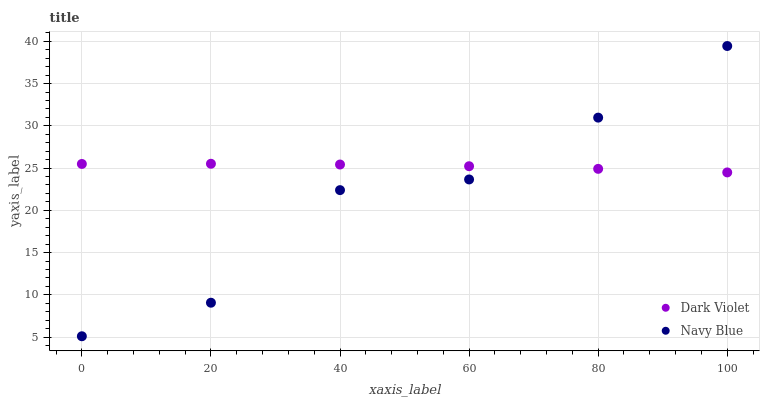Does Navy Blue have the minimum area under the curve?
Answer yes or no. Yes. Does Dark Violet have the maximum area under the curve?
Answer yes or no. Yes. Does Dark Violet have the minimum area under the curve?
Answer yes or no. No. Is Dark Violet the smoothest?
Answer yes or no. Yes. Is Navy Blue the roughest?
Answer yes or no. Yes. Is Dark Violet the roughest?
Answer yes or no. No. Does Navy Blue have the lowest value?
Answer yes or no. Yes. Does Dark Violet have the lowest value?
Answer yes or no. No. Does Navy Blue have the highest value?
Answer yes or no. Yes. Does Dark Violet have the highest value?
Answer yes or no. No. Does Dark Violet intersect Navy Blue?
Answer yes or no. Yes. Is Dark Violet less than Navy Blue?
Answer yes or no. No. Is Dark Violet greater than Navy Blue?
Answer yes or no. No. 